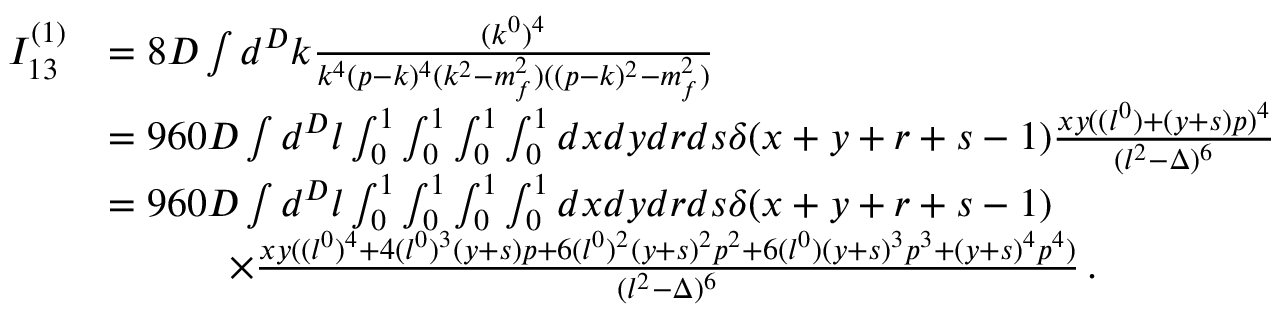<formula> <loc_0><loc_0><loc_500><loc_500>\begin{array} { r l } { I _ { 1 3 } ^ { ( 1 ) } } & { = 8 D \int d ^ { D } k \frac { ( k ^ { 0 } ) ^ { 4 } } { k ^ { 4 } ( p - k ) ^ { 4 } ( k ^ { 2 } - m _ { f } ^ { 2 } ) ( ( p - k ) ^ { 2 } - m _ { f } ^ { 2 } ) } } \\ & { = 9 6 0 D \int d ^ { D } l \int _ { 0 } ^ { 1 } \int _ { 0 } ^ { 1 } \int _ { 0 } ^ { 1 } \int _ { 0 } ^ { 1 } d x d y d r d s \delta ( x + y + r + s - 1 ) \frac { x y ( ( l ^ { 0 } ) + ( y + s ) p ) ^ { 4 } } { ( l ^ { 2 } - \Delta ) ^ { 6 } } } \\ & { = 9 6 0 D \int d ^ { D } l \int _ { 0 } ^ { 1 } \int _ { 0 } ^ { 1 } \int _ { 0 } ^ { 1 } \int _ { 0 } ^ { 1 } d x d y d r d s \delta ( x + y + r + s - 1 ) } \\ & { \quad \times \frac { x y ( ( l ^ { 0 } ) ^ { 4 } + 4 ( l ^ { 0 } ) ^ { 3 } ( y + s ) p + 6 ( l ^ { 0 } ) ^ { 2 } ( y + s ) ^ { 2 } p ^ { 2 } + 6 ( l ^ { 0 } ) ( y + s ) ^ { 3 } p ^ { 3 } + ( y + s ) ^ { 4 } p ^ { 4 } ) } { ( l ^ { 2 } - \Delta ) ^ { 6 } } \, . } \end{array}</formula> 